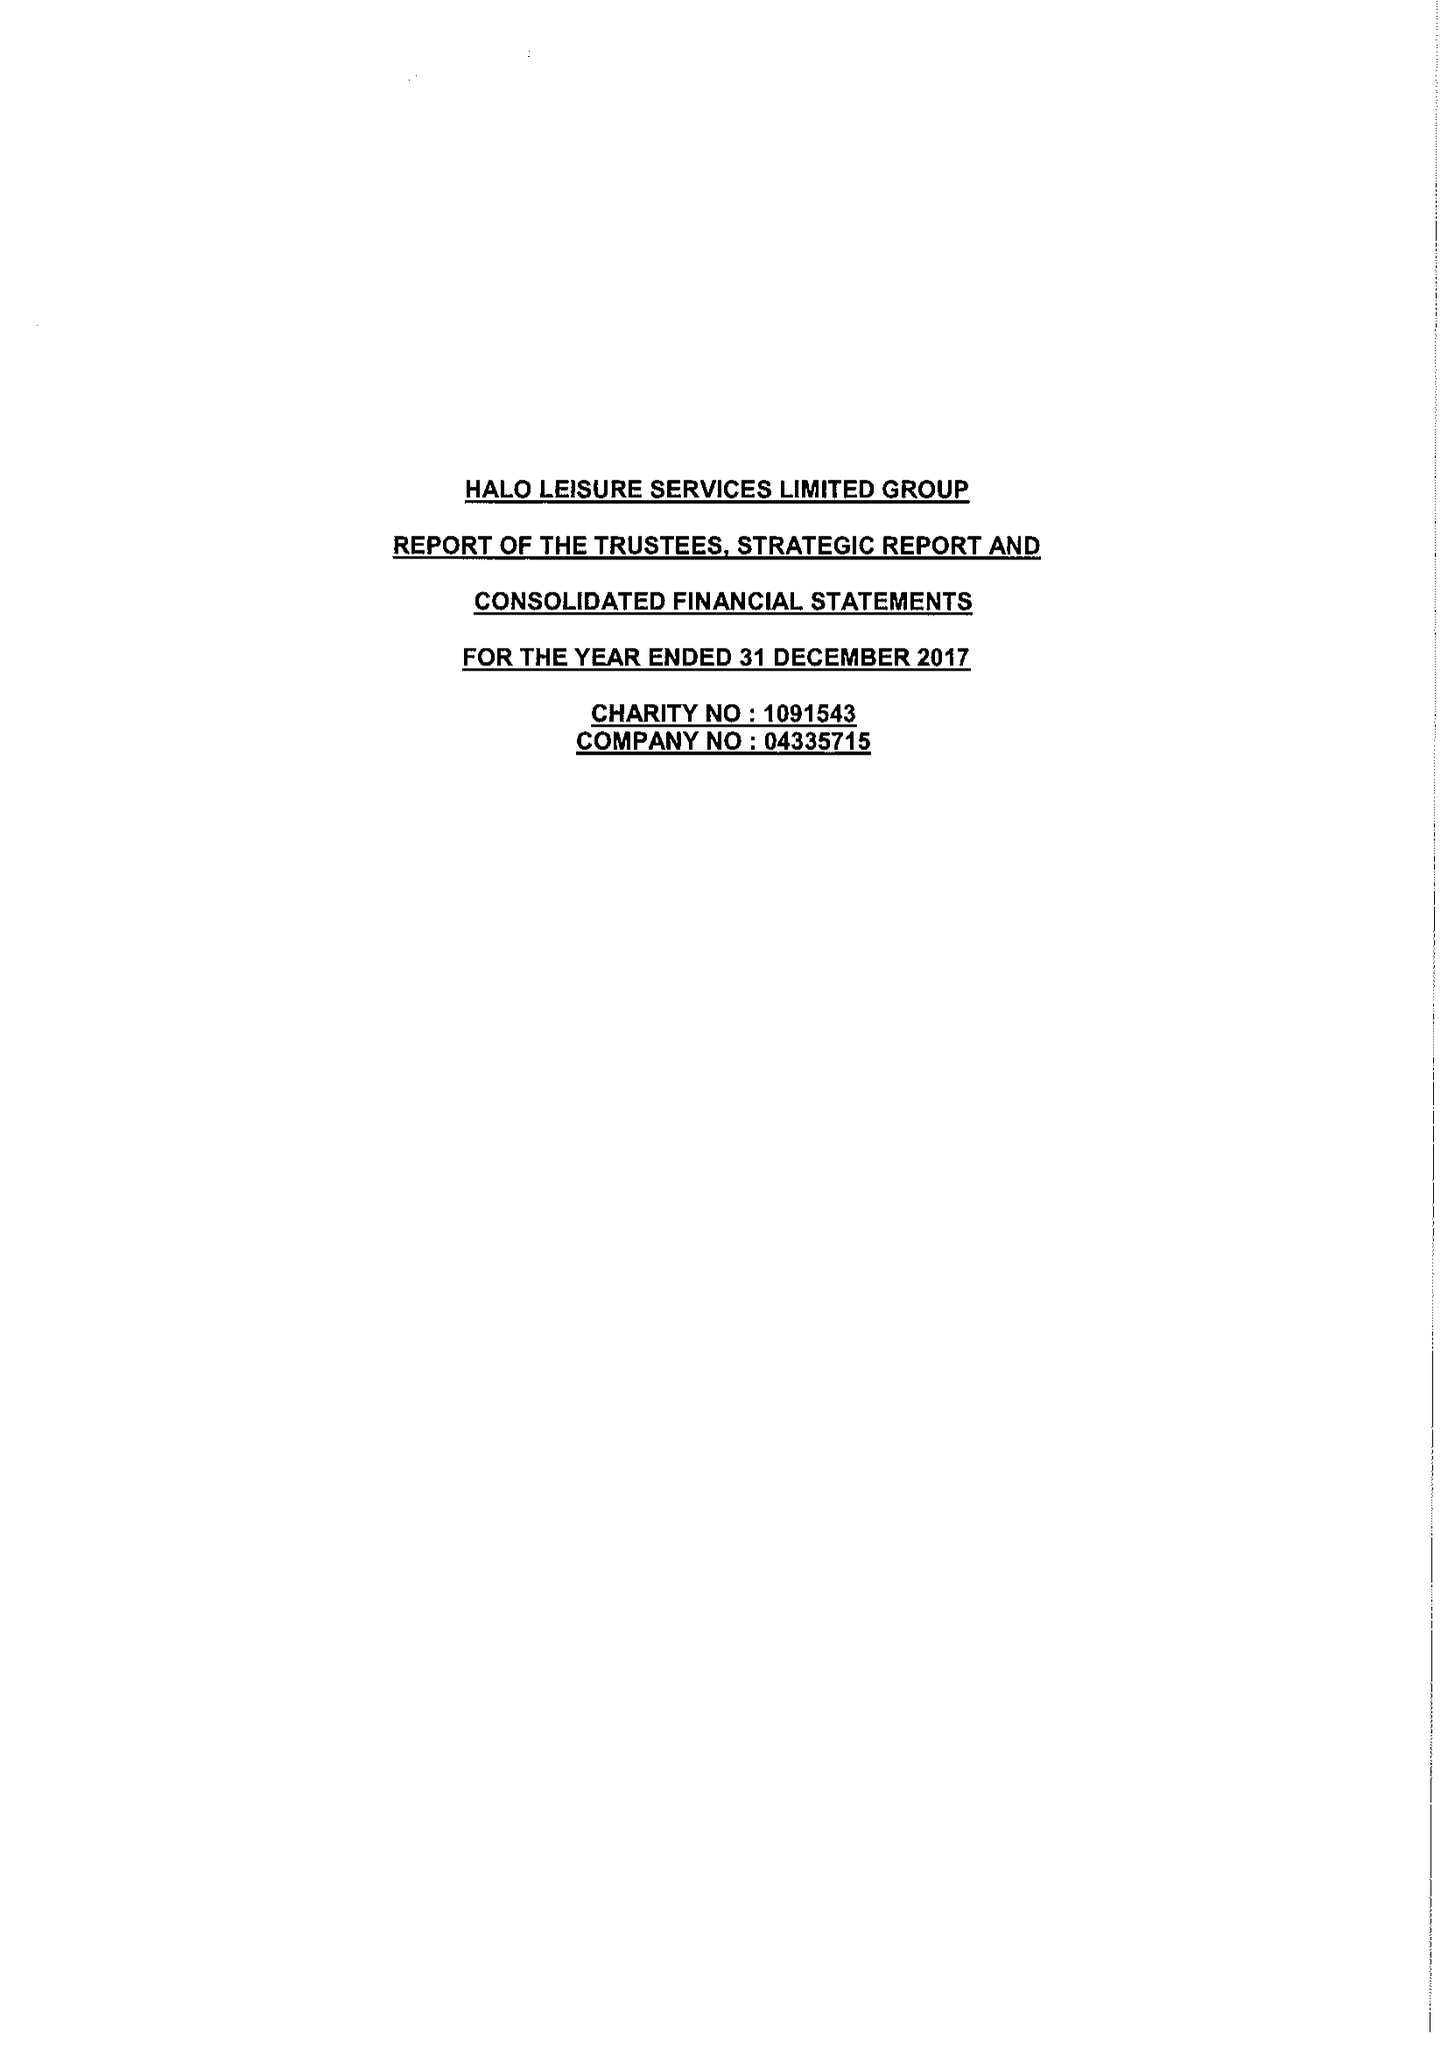What is the value for the charity_name?
Answer the question using a single word or phrase. Halo Leisure Services Ltd. 